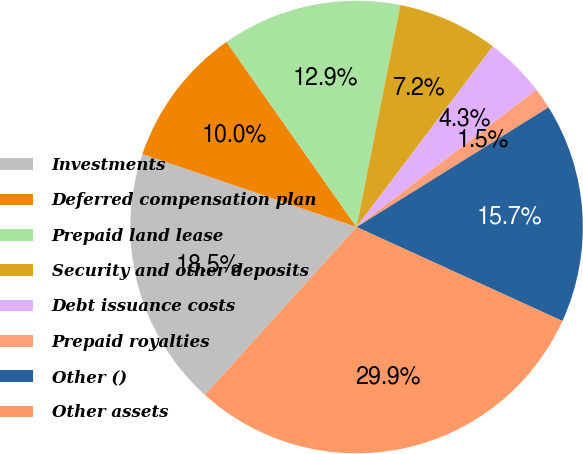Convert chart to OTSL. <chart><loc_0><loc_0><loc_500><loc_500><pie_chart><fcel>Investments<fcel>Deferred compensation plan<fcel>Prepaid land lease<fcel>Security and other deposits<fcel>Debt issuance costs<fcel>Prepaid royalties<fcel>Other ()<fcel>Other assets<nl><fcel>18.53%<fcel>10.02%<fcel>12.85%<fcel>7.18%<fcel>4.34%<fcel>1.5%<fcel>15.69%<fcel>29.88%<nl></chart> 